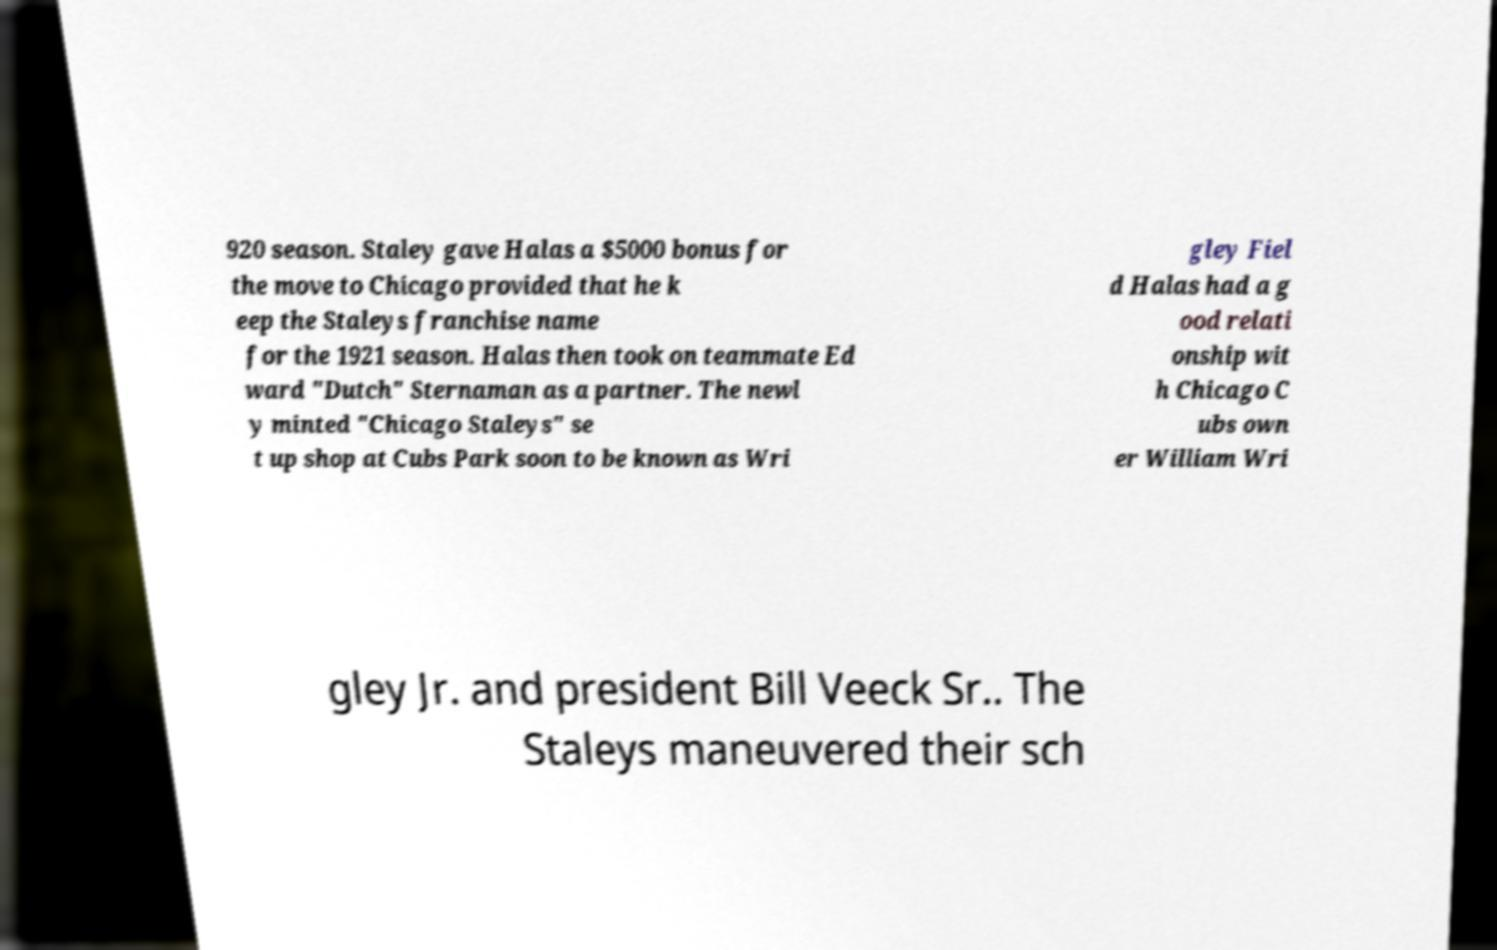What messages or text are displayed in this image? I need them in a readable, typed format. 920 season. Staley gave Halas a $5000 bonus for the move to Chicago provided that he k eep the Staleys franchise name for the 1921 season. Halas then took on teammate Ed ward "Dutch" Sternaman as a partner. The newl y minted "Chicago Staleys" se t up shop at Cubs Park soon to be known as Wri gley Fiel d Halas had a g ood relati onship wit h Chicago C ubs own er William Wri gley Jr. and president Bill Veeck Sr.. The Staleys maneuvered their sch 